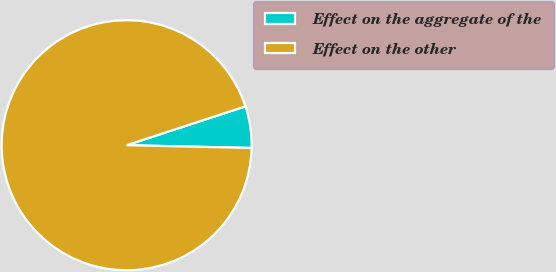<chart> <loc_0><loc_0><loc_500><loc_500><pie_chart><fcel>Effect on the aggregate of the<fcel>Effect on the other<nl><fcel>5.38%<fcel>94.62%<nl></chart> 